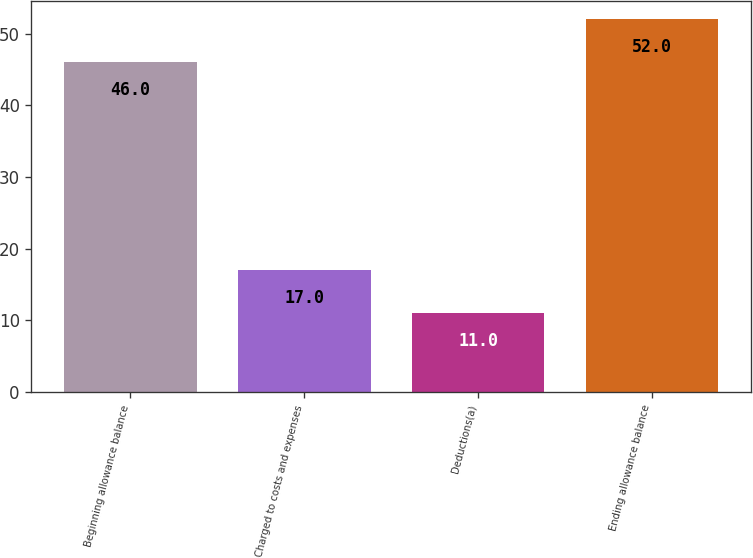Convert chart. <chart><loc_0><loc_0><loc_500><loc_500><bar_chart><fcel>Beginning allowance balance<fcel>Charged to costs and expenses<fcel>Deductions(a)<fcel>Ending allowance balance<nl><fcel>46<fcel>17<fcel>11<fcel>52<nl></chart> 